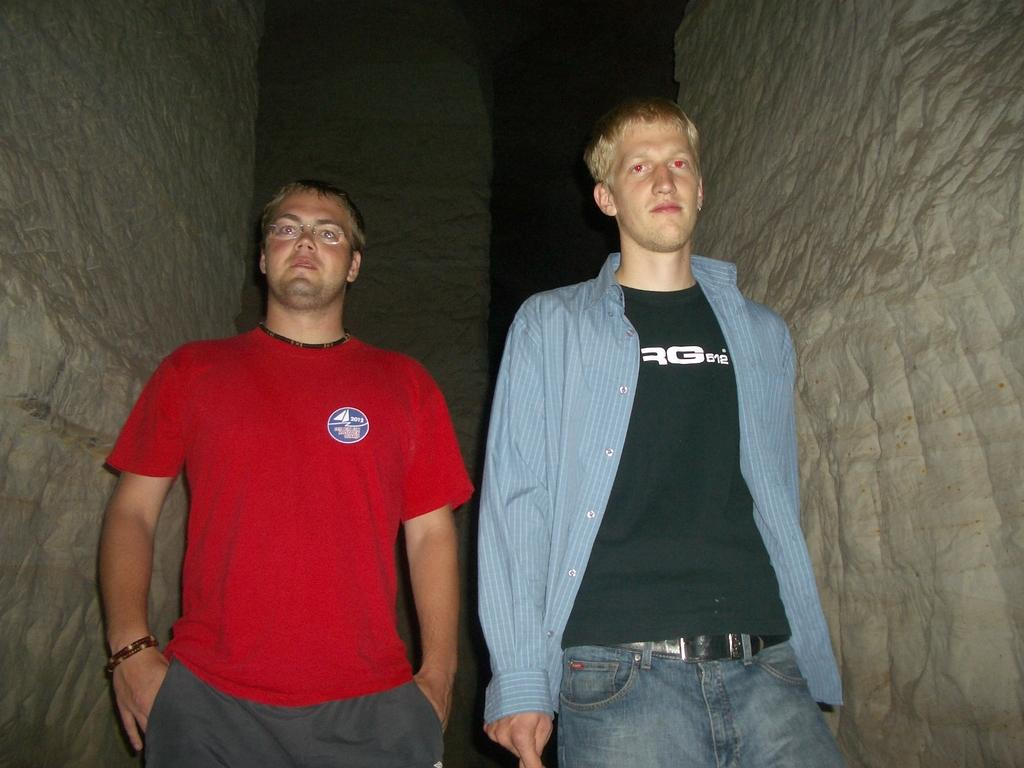How many people are present in the image? There are two persons standing in the image. What can be seen in the background of the image? There is a wall in the background of the image. What type of glue is being used by the persons in the image? There is no glue present in the image; it only features two persons standing and a wall in the background. 